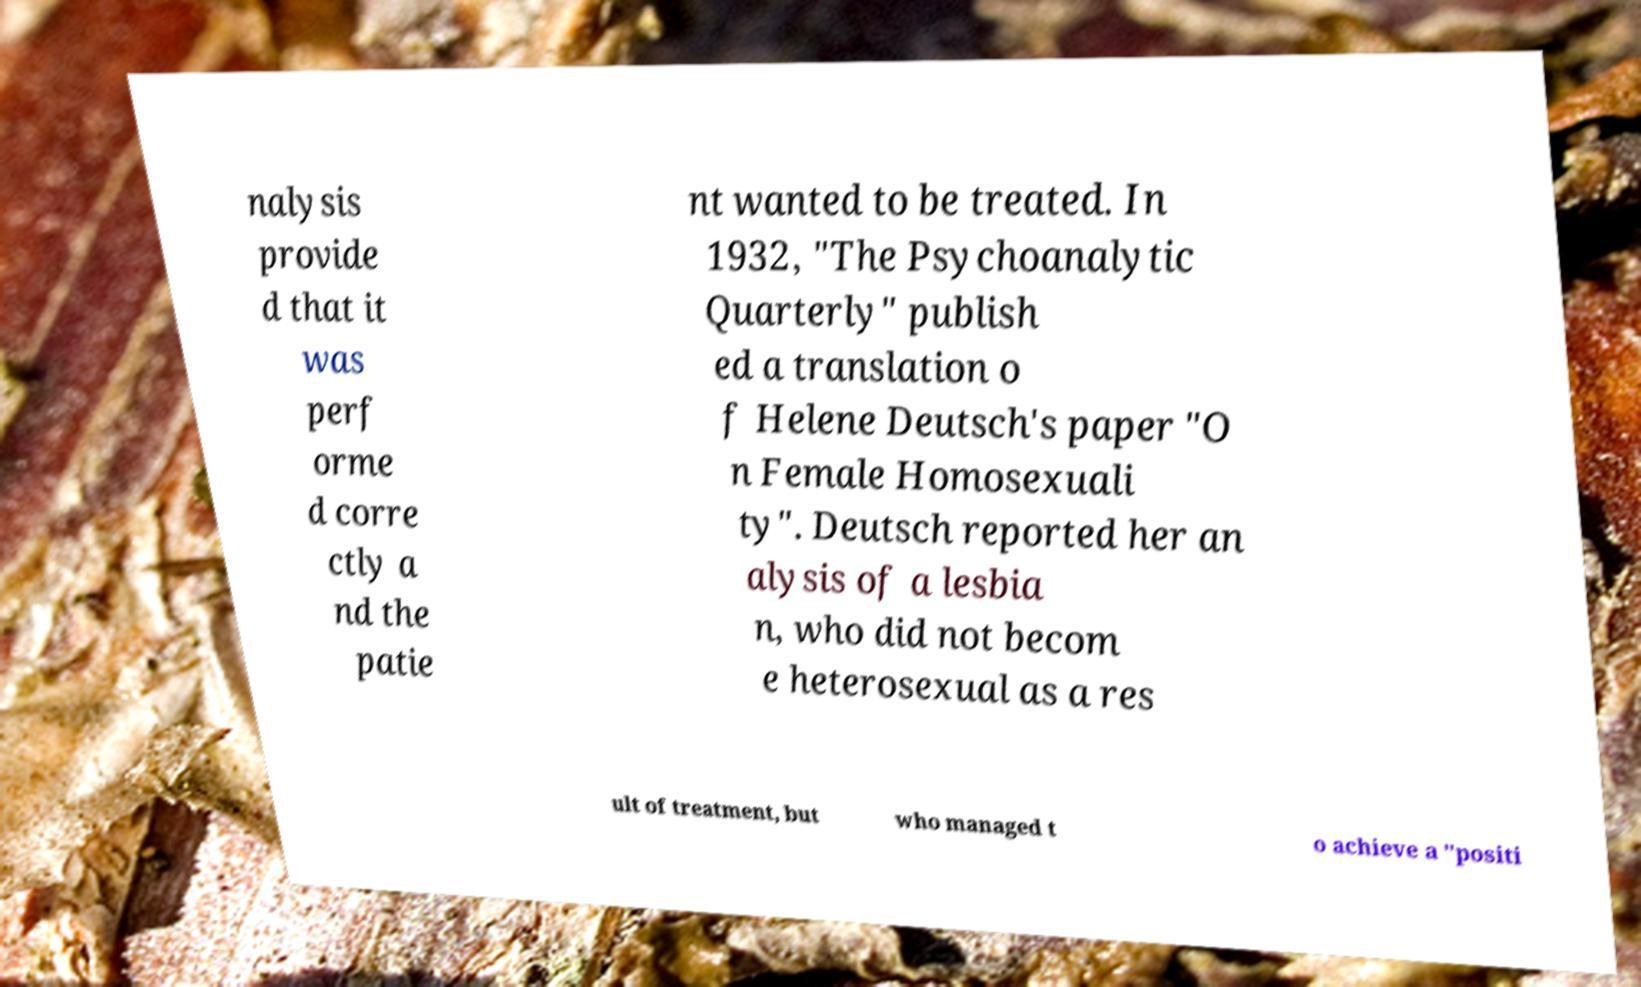Please identify and transcribe the text found in this image. nalysis provide d that it was perf orme d corre ctly a nd the patie nt wanted to be treated. In 1932, "The Psychoanalytic Quarterly" publish ed a translation o f Helene Deutsch's paper "O n Female Homosexuali ty". Deutsch reported her an alysis of a lesbia n, who did not becom e heterosexual as a res ult of treatment, but who managed t o achieve a "positi 